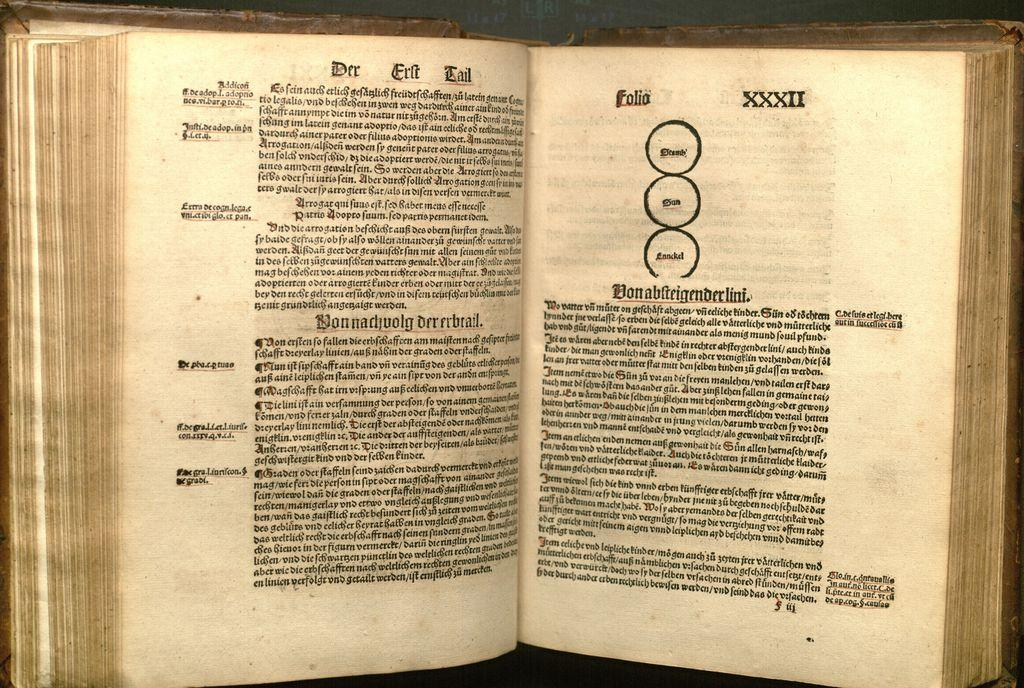Provide a one-sentence caption for the provided image. An open book with the left page title being Der Erlt Tail. 